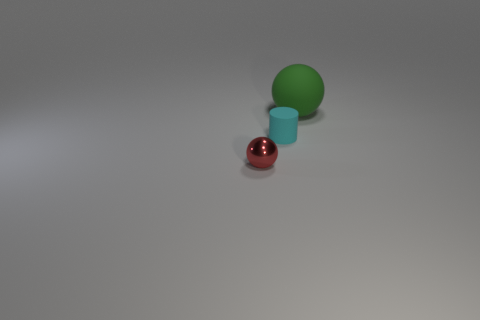Is there any other thing that has the same material as the red sphere?
Offer a very short reply. No. Is there anything else that is the same size as the green rubber thing?
Ensure brevity in your answer.  No. Are there fewer balls that are on the left side of the cyan object than things that are on the right side of the shiny sphere?
Give a very brief answer. Yes. How many other objects are the same material as the cylinder?
Your answer should be very brief. 1. There is a red thing that is the same size as the cyan object; what is its material?
Your answer should be compact. Metal. What number of red things are tiny shiny things or big matte spheres?
Provide a short and direct response. 1. What color is the thing that is behind the tiny shiny object and on the left side of the green matte object?
Offer a very short reply. Cyan. Do the small thing that is right of the red sphere and the ball that is right of the cylinder have the same material?
Provide a succinct answer. Yes. Are there more tiny shiny objects in front of the big rubber sphere than small cyan things on the left side of the small shiny object?
Your answer should be very brief. Yes. There is a red metal thing that is the same size as the cyan rubber object; what shape is it?
Provide a short and direct response. Sphere. 